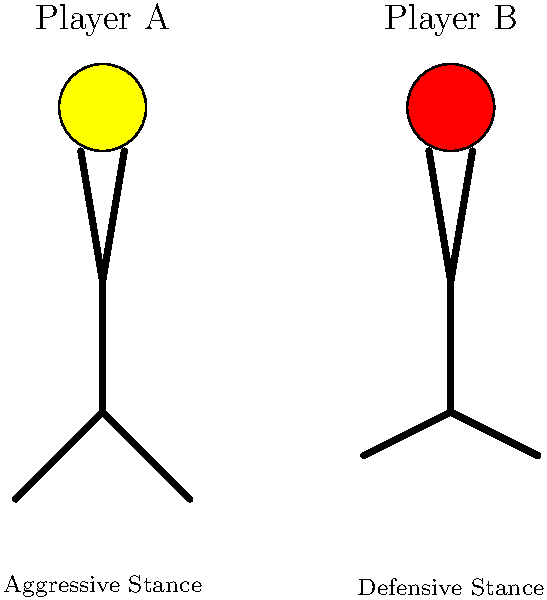Based on the serve stance images of two tennis players, which player is more likely to win the match and why? To predict the winner of a tennis match based on player stance images at serve, we need to consider several factors:

1. Stance analysis:
   - Player A exhibits an aggressive stance, with a more forward-leaning posture.
   - Player B shows a defensive stance, with a more upright and balanced position.

2. Implications of stance:
   - Aggressive stance (Player A) typically indicates:
     a) More power generation in serves
     b) Higher risk, higher reward strategy
     c) Potential for more aces and winner shots

   - Defensive stance (Player B) typically suggests:
     a) More consistent and accurate serves
     b) Better prepared for return shots
     c) Potentially longer rallies and fewer unforced errors

3. Match dynamics:
   - Aggressive players often have an advantage in shorter matches or tiebreakers
   - Defensive players may have an edge in longer matches due to consistency

4. Statistical considerations:
   - Historical data shows that aggressive players tend to win more matches at the highest levels of tennis
   - However, individual player skills, fitness, and mental strength also play crucial roles

5. Machine Learning approach:
   - A ML model would likely consider additional factors such as:
     a) Player rankings and recent form
     b) Head-to-head records
     c) Court surface and tournament conditions

Considering all these factors, Player A with the aggressive stance is slightly more likely to win the match. However, it's important to note that stance alone is not a definitive predictor of match outcomes, and other factors should be considered for a more accurate prediction.
Answer: Player A (aggressive stance) is slightly more likely to win. 